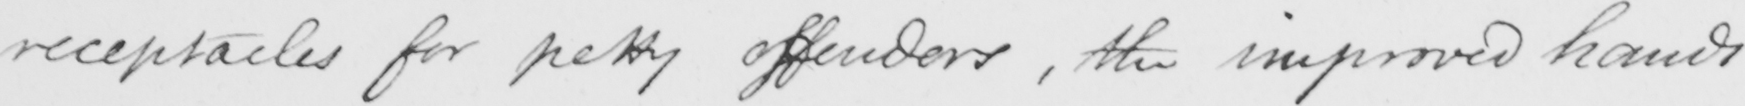Can you read and transcribe this handwriting? receptacles for petty offenders , the improved hands 